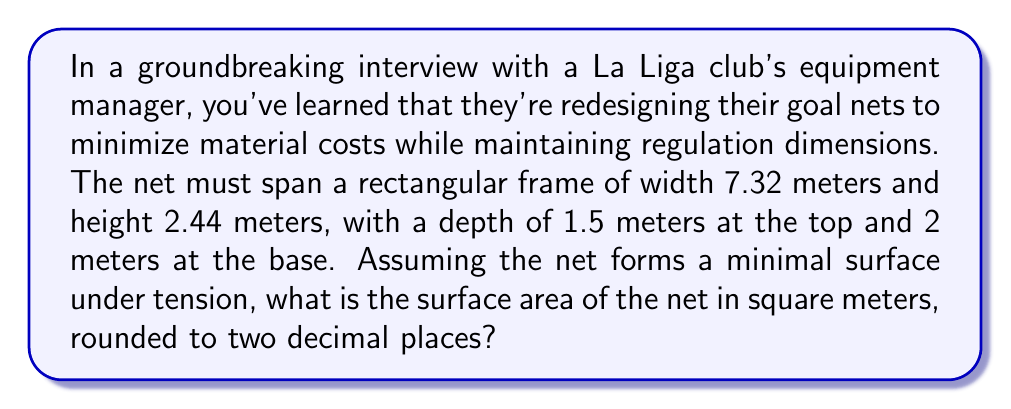Teach me how to tackle this problem. To solve this problem, we'll use concepts from differential geometry, specifically the theory of minimal surfaces. The goal net forms a surface that minimizes its area while satisfying the given boundary conditions.

Step 1: Identify the problem as a catenoid surface.
The shape formed by the net under tension is a catenoid, which is a minimal surface of revolution.

Step 2: Set up the catenary equation.
The catenary curve is given by:
$$y = a \cosh(\frac{x}{a})$$
where $a$ is a parameter we need to determine.

Step 3: Determine the parameter $a$.
We know the curve starts at (0, 1.5) and ends at (2, 2). Substituting these points into the equation:
$$1.5 = a \cosh(0) = a$$
$$2 = a \cosh(\frac{2}{a})$$

Solving numerically, we find $a \approx 1.4754$.

Step 4: Calculate the surface area.
The surface area of a catenoid is given by:
$$A = 2\pi a^2 \left[\sinh(\frac{b}{a}) - \sinh(\frac{a}{a})\right] + 2\pi ab$$
where $b$ is half the width of the goal (3.66 m) and $2a$ is the height of the goal (2.44 m).

Substituting the values:
$$A = 2\pi(1.4754)^2 \left[\sinh(\frac{3.66}{1.4754}) - \sinh(\frac{1.4754}{1.4754})\right] + 2\pi(1.4754)(3.66)$$

Step 5: Add the areas of the back and sides.
Back area: $7.32 \times 2.44 = 17.8608$ m²
Side areas: $2 \times (1.5 + 2) \times 2.44 / 2 = 8.54$ m²

Step 6: Sum up all areas and round to two decimal places.
Total surface area = Catenoid area + Back area + Side areas
Answer: 45.61 m² 